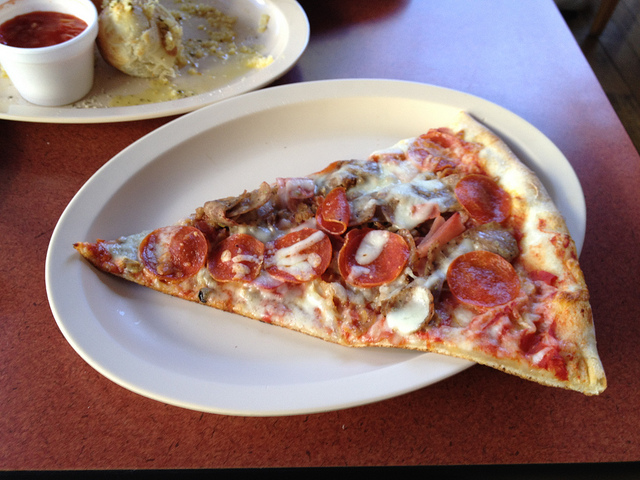What kind of occasion or setting do you think this slice of pizza is best suited for? This delectable slice, with its hearty toppings and rustic presentation, beckons a relaxed yet sociable gathering. It's ideal for a casual dinner party or a family game night where comfort and enjoyment are on the menu. Imagine indulging in this slice while laughter and light conversation fill the air, enhancing the warmth of the meal. 